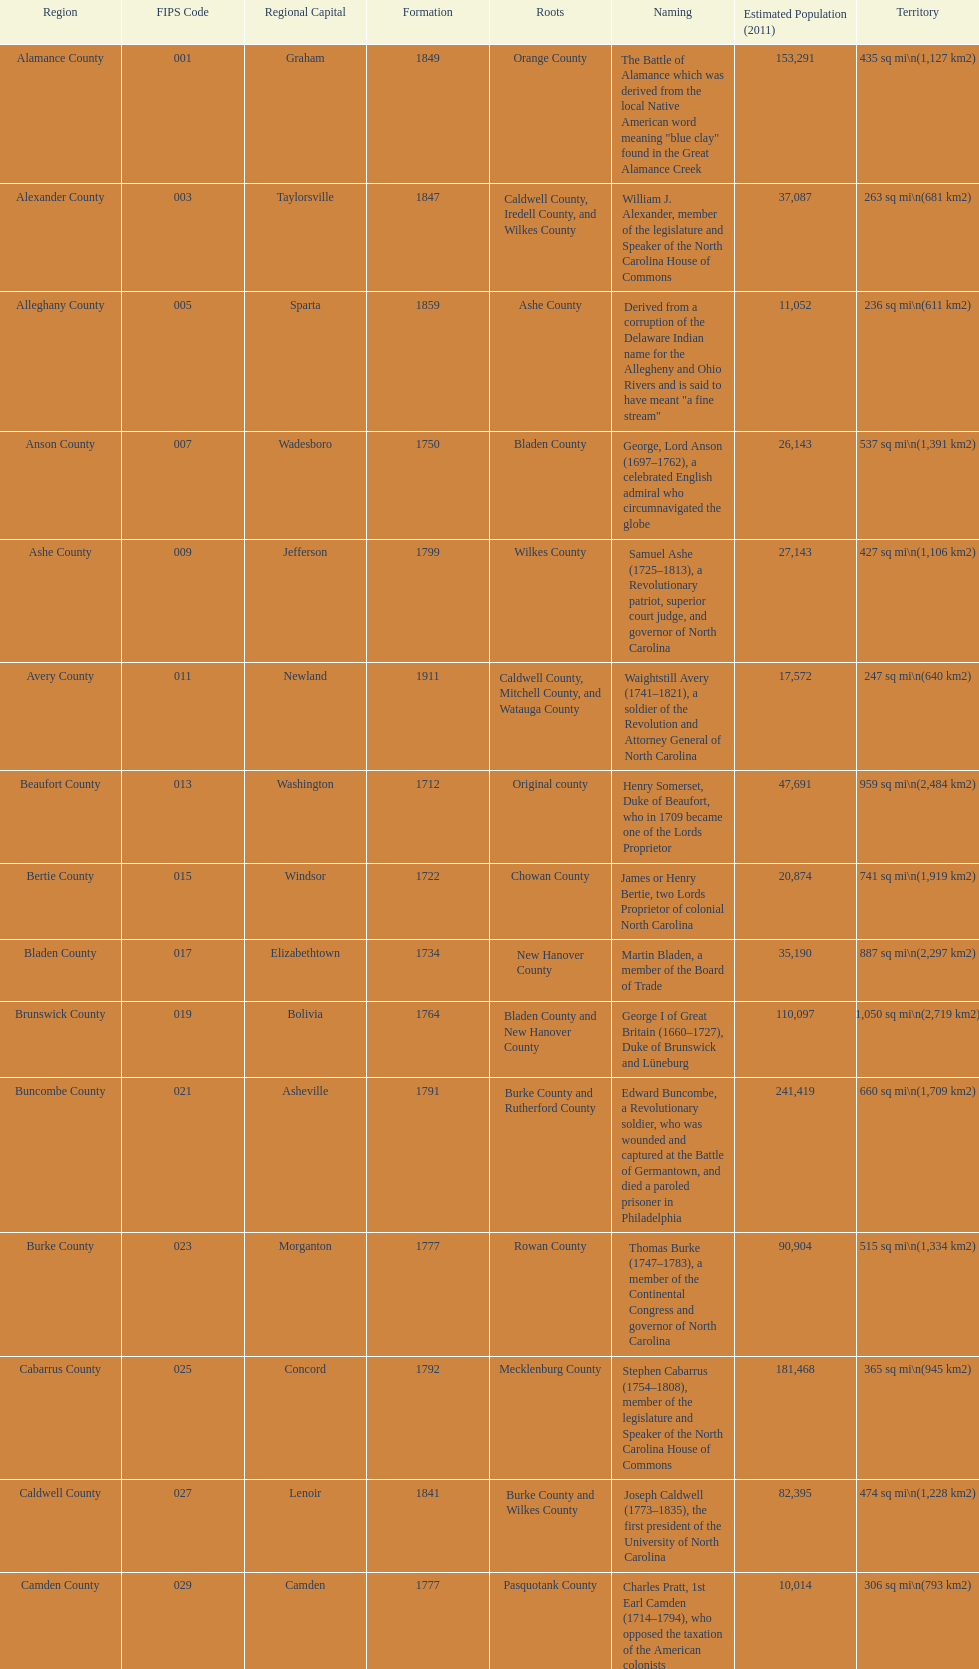Apart from mecklenburg, which county possesses the greatest number of residents? Wake County. 